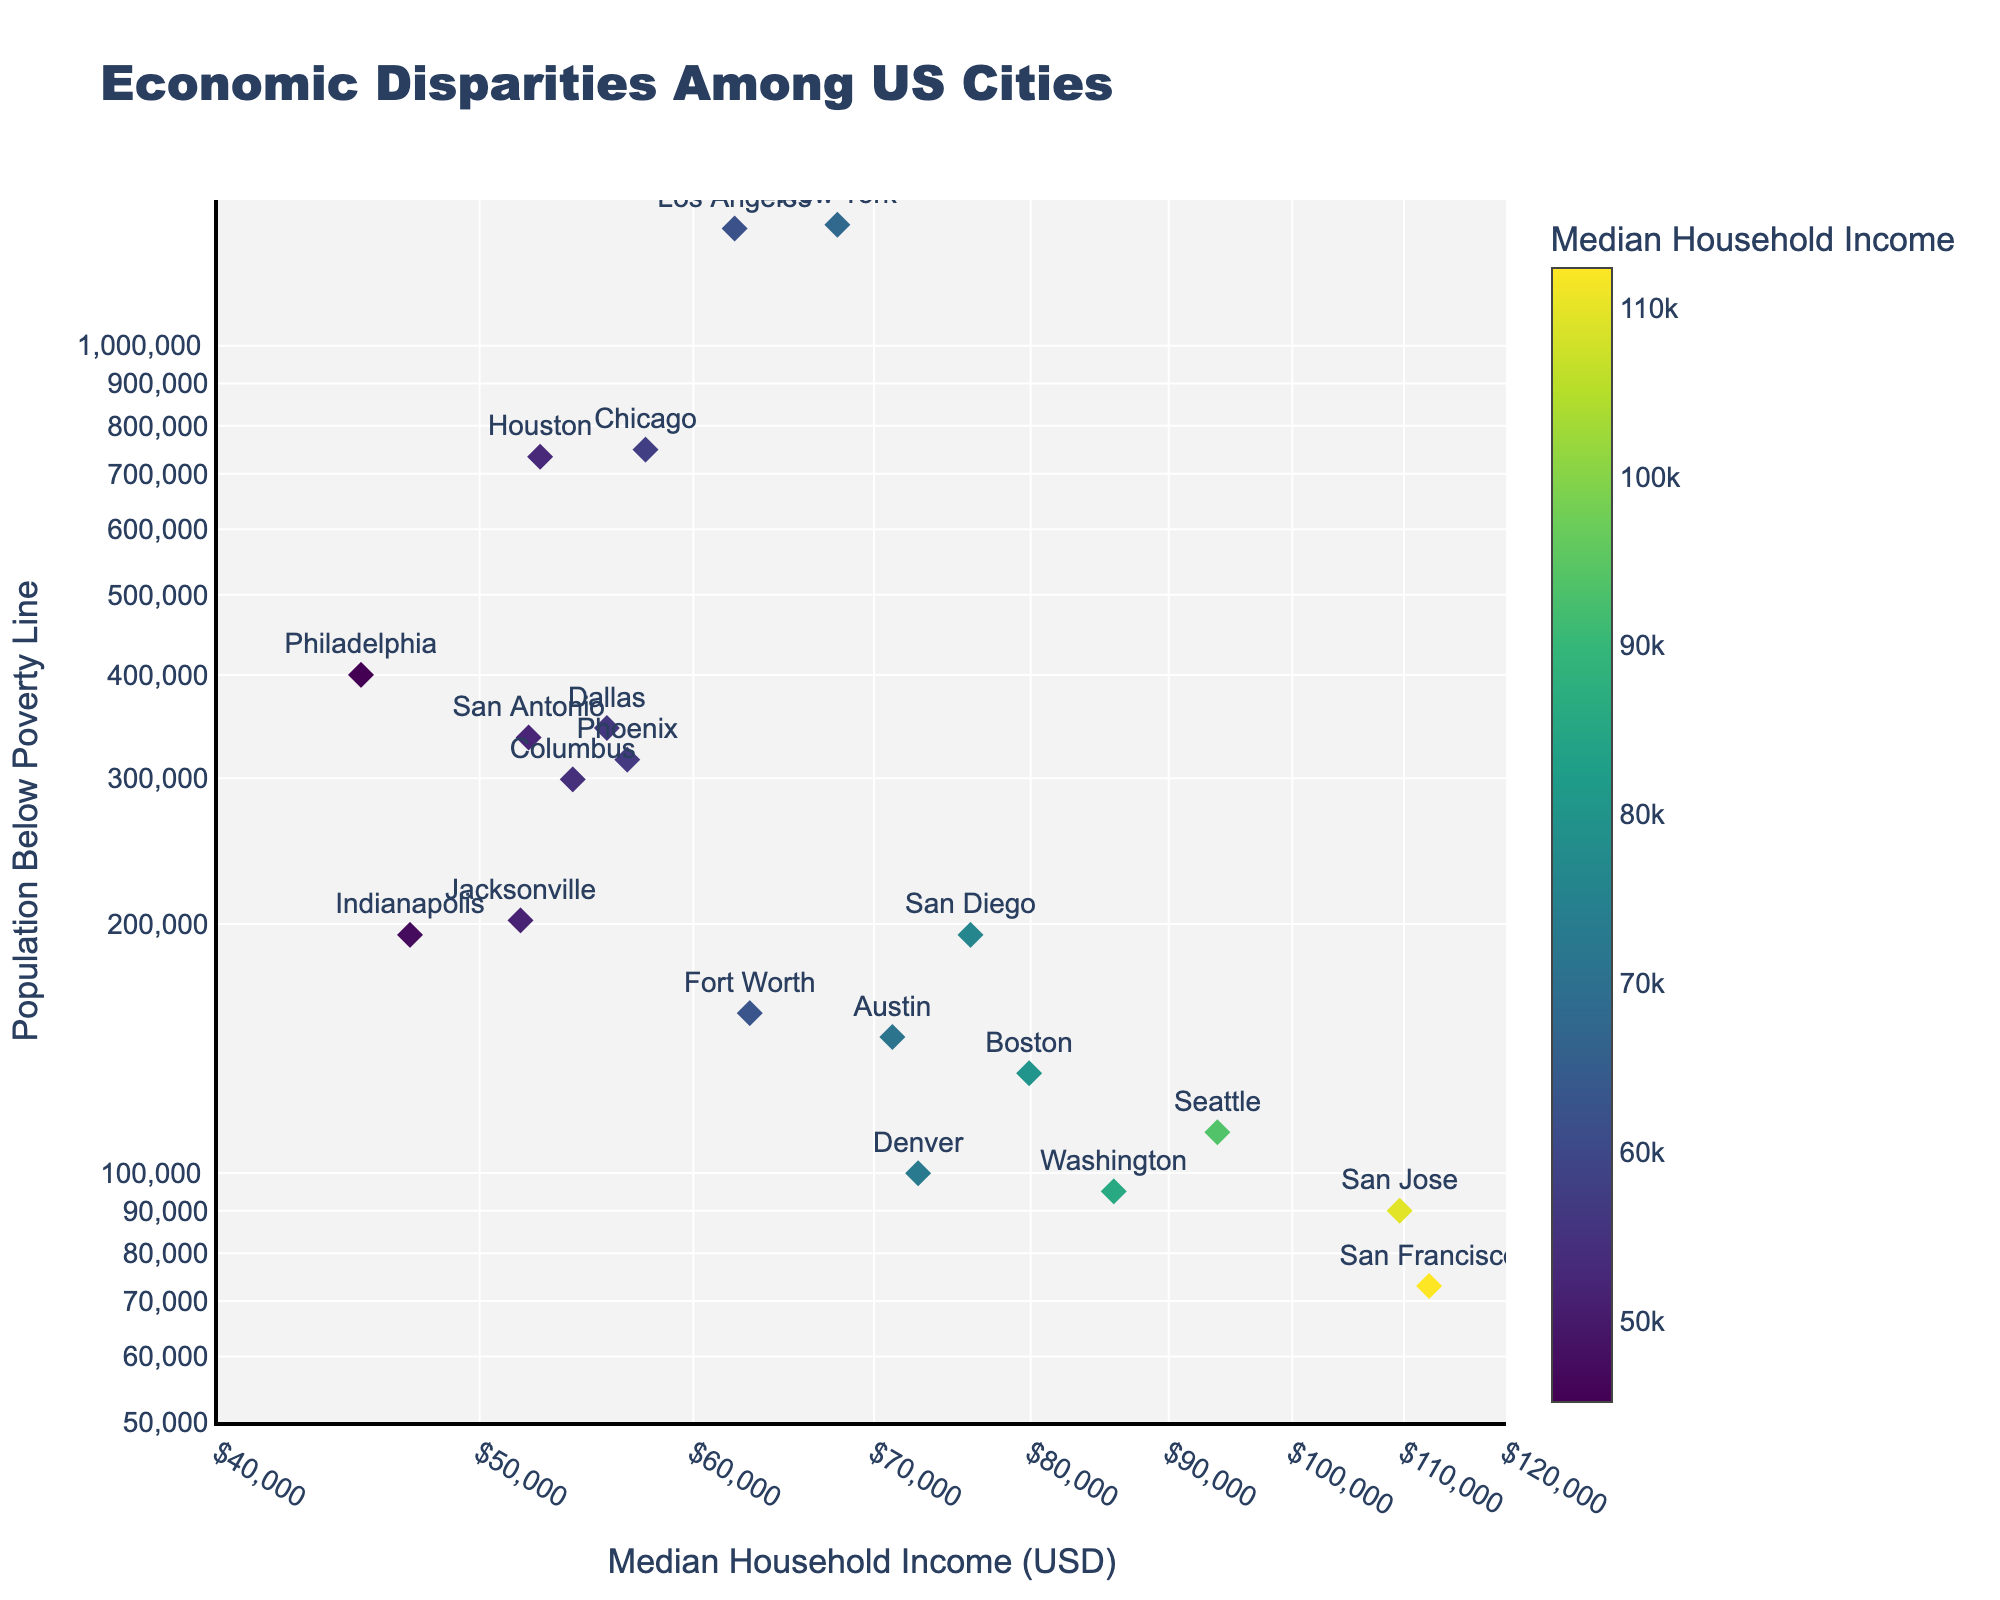How many US cities are shown in the plot? Count the number of markers, each representing a city, labeled with the city names above each marker.
Answer: 20 What is the title of the plot? Read the title displayed at the top of the plot.
Answer: Economic Disparities Among US Cities What is the median household income of the city with the highest population below the poverty line? Identify the city with the highest y-value (Population Below Poverty Line) and check its corresponding x-value (Median Household Income).
Answer: New York, $67,844 Which city has the highest median household income? Look for the marker with the highest x-value on the log scale and identify the city.
Answer: San Francisco Which city has the lowest population below the poverty line? Look for the marker with the lowest y-value on the log scale and identify the city.
Answer: San Francisco How many cities have more than 500,000 people below the poverty line? Count the markers that have y-values greater than 500,000 on the log scale.
Answer: 7 What is the range of median household income values represented in the plot? Examine the x-axis and identify the minimum and maximum values.
Answer: $45,184 to $112,376 Which cities have a median household income above $90,000? Identify the markers with x-values greater than 90,000 on the log scale and list the corresponding cities.
Answer: San Francisco, San Jose, Seattle Compare the populations below the poverty line for San Francisco and Los Angeles. Identify the y-values (Population Below Poverty Line) for San Francisco and Los Angeles and compare them.
Answer: Los Angeles has a higher population below the poverty line than San Francisco Are there more cities with a median household income above $70,000 or below $70,000? Count the number of markers with x-values above $70,000 and below $70,000 and compare the counts.
Answer: Below $70,000 How does population size below the poverty line tend to change as median income increases? Look at the general trend of the markers from left to right (increasing x-axis) and observe changes in y-values.
Answer: Population below the poverty line generally decreases as median income increases 